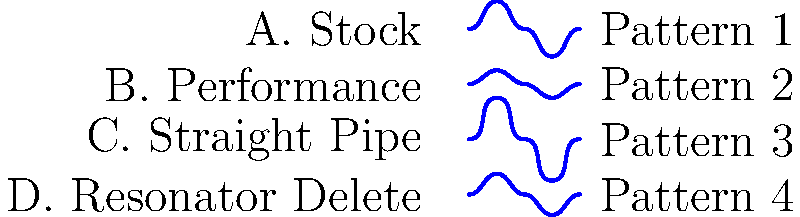As a Dodge Charger owner, match the following exhaust system configurations to their corresponding sound wave patterns:

A. Stock
B. Performance
C. Straight Pipe
D. Resonator Delete

Which configuration corresponds to each numbered pattern? To match the exhaust system configurations with their corresponding sound wave patterns, we need to consider the characteristics of each setup:

1. Stock exhaust systems are designed to balance performance and noise reduction. They typically produce a moderate sound wave with average amplitude. This corresponds to Pattern 2, which shows a balanced, medium-amplitude wave.

2. Performance exhaust systems are engineered to enhance engine output and produce a more aggressive sound. They generally create a louder, more pronounced sound wave with higher amplitude. This matches Pattern 3, which displays the highest amplitude among the options.

3. Straight pipe exhaust systems remove most restrictions, resulting in a very loud and raw sound. The sound waves produced are often more erratic and have sharp peaks. This aligns with Pattern 1, showing a more irregular wave pattern with sharp transitions.

4. Resonator delete modifications typically produce a sound between stock and straight pipe setups. They increase volume and add some raspiness without being as extreme as a straight pipe. This corresponds to Pattern 4, which shows a wave with slightly higher amplitude than stock but not as pronounced as the performance or straight pipe options.

Based on these characteristics, we can match the configurations to the patterns as follows:

A. Stock - Pattern 2
B. Performance - Pattern 3
C. Straight Pipe - Pattern 1
D. Resonator Delete - Pattern 4
Answer: A2, B3, C1, D4 